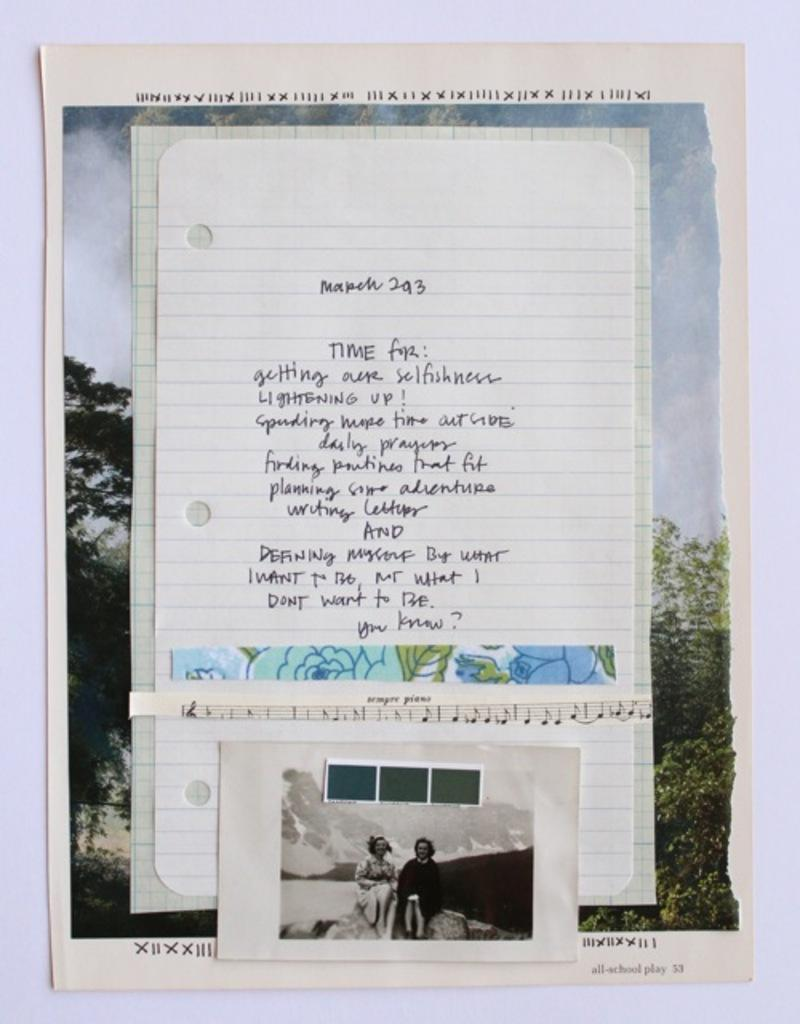<image>
Create a compact narrative representing the image presented. A piece of notebook paper has writing on it that says, "Time for" and includes a black and white photograph. 